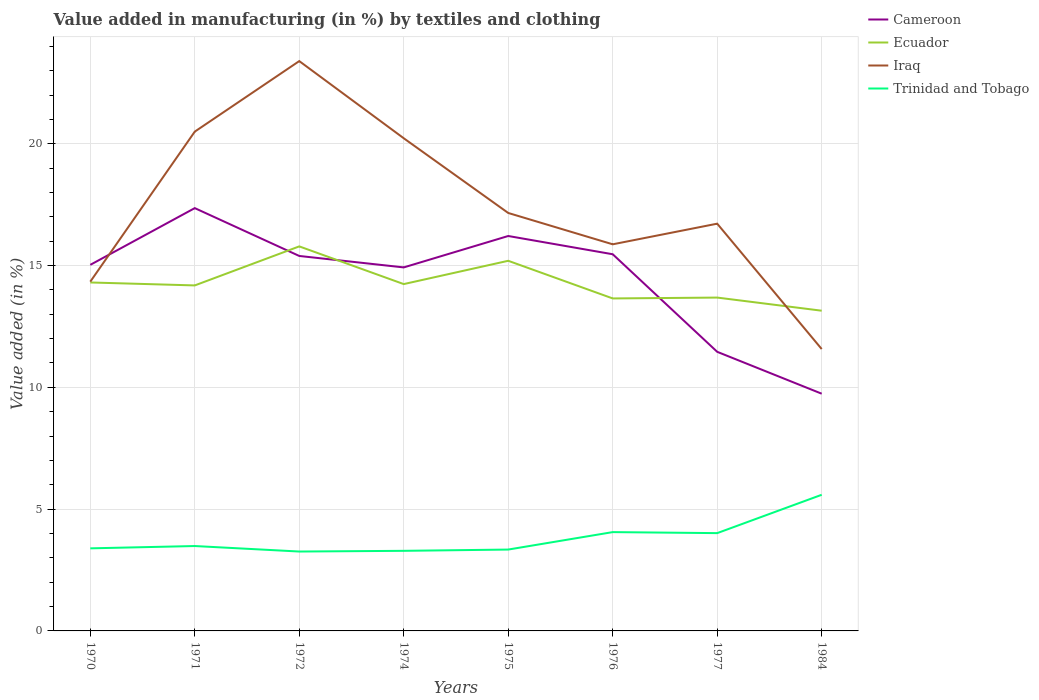Is the number of lines equal to the number of legend labels?
Your response must be concise. Yes. Across all years, what is the maximum percentage of value added in manufacturing by textiles and clothing in Trinidad and Tobago?
Keep it short and to the point. 3.26. In which year was the percentage of value added in manufacturing by textiles and clothing in Iraq maximum?
Offer a terse response. 1984. What is the total percentage of value added in manufacturing by textiles and clothing in Iraq in the graph?
Ensure brevity in your answer.  4.63. What is the difference between the highest and the second highest percentage of value added in manufacturing by textiles and clothing in Ecuador?
Ensure brevity in your answer.  2.64. What is the difference between the highest and the lowest percentage of value added in manufacturing by textiles and clothing in Cameroon?
Provide a short and direct response. 6. How many lines are there?
Make the answer very short. 4. How many years are there in the graph?
Offer a very short reply. 8. What is the difference between two consecutive major ticks on the Y-axis?
Provide a succinct answer. 5. Does the graph contain any zero values?
Offer a very short reply. No. Does the graph contain grids?
Your answer should be compact. Yes. Where does the legend appear in the graph?
Your answer should be compact. Top right. How many legend labels are there?
Provide a succinct answer. 4. How are the legend labels stacked?
Your answer should be compact. Vertical. What is the title of the graph?
Ensure brevity in your answer.  Value added in manufacturing (in %) by textiles and clothing. What is the label or title of the Y-axis?
Ensure brevity in your answer.  Value added (in %). What is the Value added (in %) in Cameroon in 1970?
Make the answer very short. 15.03. What is the Value added (in %) of Ecuador in 1970?
Make the answer very short. 14.31. What is the Value added (in %) of Iraq in 1970?
Keep it short and to the point. 14.34. What is the Value added (in %) in Trinidad and Tobago in 1970?
Offer a very short reply. 3.39. What is the Value added (in %) in Cameroon in 1971?
Provide a short and direct response. 17.36. What is the Value added (in %) of Ecuador in 1971?
Give a very brief answer. 14.18. What is the Value added (in %) of Iraq in 1971?
Keep it short and to the point. 20.5. What is the Value added (in %) in Trinidad and Tobago in 1971?
Provide a short and direct response. 3.49. What is the Value added (in %) in Cameroon in 1972?
Give a very brief answer. 15.39. What is the Value added (in %) in Ecuador in 1972?
Provide a succinct answer. 15.79. What is the Value added (in %) in Iraq in 1972?
Give a very brief answer. 23.39. What is the Value added (in %) of Trinidad and Tobago in 1972?
Keep it short and to the point. 3.26. What is the Value added (in %) of Cameroon in 1974?
Provide a short and direct response. 14.92. What is the Value added (in %) in Ecuador in 1974?
Offer a very short reply. 14.24. What is the Value added (in %) of Iraq in 1974?
Provide a succinct answer. 20.23. What is the Value added (in %) of Trinidad and Tobago in 1974?
Your answer should be compact. 3.29. What is the Value added (in %) in Cameroon in 1975?
Keep it short and to the point. 16.21. What is the Value added (in %) of Ecuador in 1975?
Offer a terse response. 15.19. What is the Value added (in %) in Iraq in 1975?
Provide a short and direct response. 17.16. What is the Value added (in %) of Trinidad and Tobago in 1975?
Ensure brevity in your answer.  3.34. What is the Value added (in %) of Cameroon in 1976?
Your answer should be very brief. 15.46. What is the Value added (in %) of Ecuador in 1976?
Ensure brevity in your answer.  13.65. What is the Value added (in %) of Iraq in 1976?
Provide a succinct answer. 15.87. What is the Value added (in %) of Trinidad and Tobago in 1976?
Provide a short and direct response. 4.06. What is the Value added (in %) in Cameroon in 1977?
Ensure brevity in your answer.  11.46. What is the Value added (in %) in Ecuador in 1977?
Give a very brief answer. 13.68. What is the Value added (in %) in Iraq in 1977?
Provide a short and direct response. 16.72. What is the Value added (in %) of Trinidad and Tobago in 1977?
Keep it short and to the point. 4.01. What is the Value added (in %) of Cameroon in 1984?
Keep it short and to the point. 9.74. What is the Value added (in %) of Ecuador in 1984?
Give a very brief answer. 13.15. What is the Value added (in %) in Iraq in 1984?
Offer a terse response. 11.57. What is the Value added (in %) of Trinidad and Tobago in 1984?
Offer a terse response. 5.59. Across all years, what is the maximum Value added (in %) in Cameroon?
Provide a short and direct response. 17.36. Across all years, what is the maximum Value added (in %) of Ecuador?
Keep it short and to the point. 15.79. Across all years, what is the maximum Value added (in %) in Iraq?
Ensure brevity in your answer.  23.39. Across all years, what is the maximum Value added (in %) in Trinidad and Tobago?
Your answer should be very brief. 5.59. Across all years, what is the minimum Value added (in %) in Cameroon?
Give a very brief answer. 9.74. Across all years, what is the minimum Value added (in %) of Ecuador?
Ensure brevity in your answer.  13.15. Across all years, what is the minimum Value added (in %) of Iraq?
Offer a terse response. 11.57. Across all years, what is the minimum Value added (in %) in Trinidad and Tobago?
Your answer should be very brief. 3.26. What is the total Value added (in %) in Cameroon in the graph?
Give a very brief answer. 115.58. What is the total Value added (in %) in Ecuador in the graph?
Offer a very short reply. 114.19. What is the total Value added (in %) of Iraq in the graph?
Offer a very short reply. 139.78. What is the total Value added (in %) of Trinidad and Tobago in the graph?
Make the answer very short. 30.42. What is the difference between the Value added (in %) of Cameroon in 1970 and that in 1971?
Make the answer very short. -2.33. What is the difference between the Value added (in %) of Ecuador in 1970 and that in 1971?
Ensure brevity in your answer.  0.12. What is the difference between the Value added (in %) in Iraq in 1970 and that in 1971?
Ensure brevity in your answer.  -6.16. What is the difference between the Value added (in %) in Trinidad and Tobago in 1970 and that in 1971?
Give a very brief answer. -0.1. What is the difference between the Value added (in %) of Cameroon in 1970 and that in 1972?
Provide a short and direct response. -0.36. What is the difference between the Value added (in %) in Ecuador in 1970 and that in 1972?
Make the answer very short. -1.48. What is the difference between the Value added (in %) of Iraq in 1970 and that in 1972?
Your response must be concise. -9.06. What is the difference between the Value added (in %) in Trinidad and Tobago in 1970 and that in 1972?
Provide a succinct answer. 0.13. What is the difference between the Value added (in %) in Cameroon in 1970 and that in 1974?
Provide a succinct answer. 0.11. What is the difference between the Value added (in %) of Ecuador in 1970 and that in 1974?
Offer a very short reply. 0.07. What is the difference between the Value added (in %) of Iraq in 1970 and that in 1974?
Offer a very short reply. -5.89. What is the difference between the Value added (in %) in Trinidad and Tobago in 1970 and that in 1974?
Offer a very short reply. 0.1. What is the difference between the Value added (in %) in Cameroon in 1970 and that in 1975?
Make the answer very short. -1.18. What is the difference between the Value added (in %) of Ecuador in 1970 and that in 1975?
Keep it short and to the point. -0.89. What is the difference between the Value added (in %) of Iraq in 1970 and that in 1975?
Keep it short and to the point. -2.82. What is the difference between the Value added (in %) of Trinidad and Tobago in 1970 and that in 1975?
Make the answer very short. 0.05. What is the difference between the Value added (in %) in Cameroon in 1970 and that in 1976?
Make the answer very short. -0.43. What is the difference between the Value added (in %) in Ecuador in 1970 and that in 1976?
Your answer should be compact. 0.66. What is the difference between the Value added (in %) of Iraq in 1970 and that in 1976?
Your answer should be compact. -1.53. What is the difference between the Value added (in %) of Trinidad and Tobago in 1970 and that in 1976?
Ensure brevity in your answer.  -0.67. What is the difference between the Value added (in %) of Cameroon in 1970 and that in 1977?
Your answer should be very brief. 3.57. What is the difference between the Value added (in %) of Ecuador in 1970 and that in 1977?
Provide a short and direct response. 0.62. What is the difference between the Value added (in %) in Iraq in 1970 and that in 1977?
Offer a terse response. -2.38. What is the difference between the Value added (in %) of Trinidad and Tobago in 1970 and that in 1977?
Offer a very short reply. -0.62. What is the difference between the Value added (in %) in Cameroon in 1970 and that in 1984?
Provide a succinct answer. 5.29. What is the difference between the Value added (in %) in Ecuador in 1970 and that in 1984?
Ensure brevity in your answer.  1.16. What is the difference between the Value added (in %) in Iraq in 1970 and that in 1984?
Your answer should be very brief. 2.77. What is the difference between the Value added (in %) in Trinidad and Tobago in 1970 and that in 1984?
Provide a succinct answer. -2.2. What is the difference between the Value added (in %) in Cameroon in 1971 and that in 1972?
Your response must be concise. 1.96. What is the difference between the Value added (in %) in Ecuador in 1971 and that in 1972?
Your response must be concise. -1.6. What is the difference between the Value added (in %) in Iraq in 1971 and that in 1972?
Provide a short and direct response. -2.9. What is the difference between the Value added (in %) in Trinidad and Tobago in 1971 and that in 1972?
Keep it short and to the point. 0.23. What is the difference between the Value added (in %) of Cameroon in 1971 and that in 1974?
Make the answer very short. 2.43. What is the difference between the Value added (in %) of Ecuador in 1971 and that in 1974?
Make the answer very short. -0.05. What is the difference between the Value added (in %) in Iraq in 1971 and that in 1974?
Provide a succinct answer. 0.27. What is the difference between the Value added (in %) in Trinidad and Tobago in 1971 and that in 1974?
Offer a very short reply. 0.2. What is the difference between the Value added (in %) in Cameroon in 1971 and that in 1975?
Your answer should be very brief. 1.14. What is the difference between the Value added (in %) in Ecuador in 1971 and that in 1975?
Ensure brevity in your answer.  -1.01. What is the difference between the Value added (in %) in Iraq in 1971 and that in 1975?
Make the answer very short. 3.34. What is the difference between the Value added (in %) of Trinidad and Tobago in 1971 and that in 1975?
Your response must be concise. 0.14. What is the difference between the Value added (in %) in Cameroon in 1971 and that in 1976?
Offer a very short reply. 1.89. What is the difference between the Value added (in %) in Ecuador in 1971 and that in 1976?
Your response must be concise. 0.53. What is the difference between the Value added (in %) of Iraq in 1971 and that in 1976?
Make the answer very short. 4.63. What is the difference between the Value added (in %) in Trinidad and Tobago in 1971 and that in 1976?
Give a very brief answer. -0.57. What is the difference between the Value added (in %) in Cameroon in 1971 and that in 1977?
Offer a very short reply. 5.9. What is the difference between the Value added (in %) in Ecuador in 1971 and that in 1977?
Provide a short and direct response. 0.5. What is the difference between the Value added (in %) of Iraq in 1971 and that in 1977?
Give a very brief answer. 3.78. What is the difference between the Value added (in %) in Trinidad and Tobago in 1971 and that in 1977?
Your answer should be very brief. -0.53. What is the difference between the Value added (in %) in Cameroon in 1971 and that in 1984?
Make the answer very short. 7.62. What is the difference between the Value added (in %) of Ecuador in 1971 and that in 1984?
Your answer should be very brief. 1.04. What is the difference between the Value added (in %) of Iraq in 1971 and that in 1984?
Your answer should be very brief. 8.93. What is the difference between the Value added (in %) of Trinidad and Tobago in 1971 and that in 1984?
Make the answer very short. -2.1. What is the difference between the Value added (in %) in Cameroon in 1972 and that in 1974?
Your answer should be very brief. 0.47. What is the difference between the Value added (in %) in Ecuador in 1972 and that in 1974?
Provide a short and direct response. 1.55. What is the difference between the Value added (in %) in Iraq in 1972 and that in 1974?
Your answer should be very brief. 3.17. What is the difference between the Value added (in %) in Trinidad and Tobago in 1972 and that in 1974?
Keep it short and to the point. -0.03. What is the difference between the Value added (in %) in Cameroon in 1972 and that in 1975?
Make the answer very short. -0.82. What is the difference between the Value added (in %) in Ecuador in 1972 and that in 1975?
Offer a terse response. 0.59. What is the difference between the Value added (in %) in Iraq in 1972 and that in 1975?
Make the answer very short. 6.24. What is the difference between the Value added (in %) in Trinidad and Tobago in 1972 and that in 1975?
Your response must be concise. -0.08. What is the difference between the Value added (in %) in Cameroon in 1972 and that in 1976?
Provide a succinct answer. -0.07. What is the difference between the Value added (in %) in Ecuador in 1972 and that in 1976?
Offer a terse response. 2.14. What is the difference between the Value added (in %) of Iraq in 1972 and that in 1976?
Provide a short and direct response. 7.52. What is the difference between the Value added (in %) in Trinidad and Tobago in 1972 and that in 1976?
Ensure brevity in your answer.  -0.8. What is the difference between the Value added (in %) of Cameroon in 1972 and that in 1977?
Offer a terse response. 3.94. What is the difference between the Value added (in %) of Ecuador in 1972 and that in 1977?
Make the answer very short. 2.1. What is the difference between the Value added (in %) in Iraq in 1972 and that in 1977?
Provide a succinct answer. 6.67. What is the difference between the Value added (in %) of Trinidad and Tobago in 1972 and that in 1977?
Offer a terse response. -0.76. What is the difference between the Value added (in %) of Cameroon in 1972 and that in 1984?
Offer a terse response. 5.65. What is the difference between the Value added (in %) of Ecuador in 1972 and that in 1984?
Ensure brevity in your answer.  2.64. What is the difference between the Value added (in %) in Iraq in 1972 and that in 1984?
Give a very brief answer. 11.82. What is the difference between the Value added (in %) in Trinidad and Tobago in 1972 and that in 1984?
Give a very brief answer. -2.33. What is the difference between the Value added (in %) of Cameroon in 1974 and that in 1975?
Give a very brief answer. -1.29. What is the difference between the Value added (in %) of Ecuador in 1974 and that in 1975?
Offer a terse response. -0.96. What is the difference between the Value added (in %) in Iraq in 1974 and that in 1975?
Make the answer very short. 3.07. What is the difference between the Value added (in %) of Trinidad and Tobago in 1974 and that in 1975?
Keep it short and to the point. -0.05. What is the difference between the Value added (in %) in Cameroon in 1974 and that in 1976?
Offer a terse response. -0.54. What is the difference between the Value added (in %) in Ecuador in 1974 and that in 1976?
Keep it short and to the point. 0.59. What is the difference between the Value added (in %) in Iraq in 1974 and that in 1976?
Your answer should be compact. 4.35. What is the difference between the Value added (in %) in Trinidad and Tobago in 1974 and that in 1976?
Keep it short and to the point. -0.77. What is the difference between the Value added (in %) in Cameroon in 1974 and that in 1977?
Offer a terse response. 3.47. What is the difference between the Value added (in %) of Ecuador in 1974 and that in 1977?
Ensure brevity in your answer.  0.55. What is the difference between the Value added (in %) in Iraq in 1974 and that in 1977?
Your answer should be compact. 3.51. What is the difference between the Value added (in %) of Trinidad and Tobago in 1974 and that in 1977?
Ensure brevity in your answer.  -0.73. What is the difference between the Value added (in %) in Cameroon in 1974 and that in 1984?
Give a very brief answer. 5.18. What is the difference between the Value added (in %) of Ecuador in 1974 and that in 1984?
Make the answer very short. 1.09. What is the difference between the Value added (in %) of Iraq in 1974 and that in 1984?
Give a very brief answer. 8.65. What is the difference between the Value added (in %) of Trinidad and Tobago in 1974 and that in 1984?
Provide a succinct answer. -2.3. What is the difference between the Value added (in %) in Cameroon in 1975 and that in 1976?
Your answer should be compact. 0.75. What is the difference between the Value added (in %) of Ecuador in 1975 and that in 1976?
Ensure brevity in your answer.  1.55. What is the difference between the Value added (in %) in Iraq in 1975 and that in 1976?
Your response must be concise. 1.29. What is the difference between the Value added (in %) of Trinidad and Tobago in 1975 and that in 1976?
Your answer should be compact. -0.72. What is the difference between the Value added (in %) of Cameroon in 1975 and that in 1977?
Give a very brief answer. 4.75. What is the difference between the Value added (in %) in Ecuador in 1975 and that in 1977?
Provide a short and direct response. 1.51. What is the difference between the Value added (in %) of Iraq in 1975 and that in 1977?
Ensure brevity in your answer.  0.44. What is the difference between the Value added (in %) of Trinidad and Tobago in 1975 and that in 1977?
Your answer should be very brief. -0.67. What is the difference between the Value added (in %) in Cameroon in 1975 and that in 1984?
Ensure brevity in your answer.  6.47. What is the difference between the Value added (in %) of Ecuador in 1975 and that in 1984?
Your answer should be very brief. 2.05. What is the difference between the Value added (in %) of Iraq in 1975 and that in 1984?
Offer a very short reply. 5.59. What is the difference between the Value added (in %) of Trinidad and Tobago in 1975 and that in 1984?
Your answer should be compact. -2.25. What is the difference between the Value added (in %) of Cameroon in 1976 and that in 1977?
Your response must be concise. 4.01. What is the difference between the Value added (in %) of Ecuador in 1976 and that in 1977?
Make the answer very short. -0.04. What is the difference between the Value added (in %) of Iraq in 1976 and that in 1977?
Provide a short and direct response. -0.85. What is the difference between the Value added (in %) of Trinidad and Tobago in 1976 and that in 1977?
Provide a succinct answer. 0.04. What is the difference between the Value added (in %) in Cameroon in 1976 and that in 1984?
Keep it short and to the point. 5.72. What is the difference between the Value added (in %) in Ecuador in 1976 and that in 1984?
Provide a succinct answer. 0.5. What is the difference between the Value added (in %) in Iraq in 1976 and that in 1984?
Provide a short and direct response. 4.3. What is the difference between the Value added (in %) in Trinidad and Tobago in 1976 and that in 1984?
Ensure brevity in your answer.  -1.53. What is the difference between the Value added (in %) in Cameroon in 1977 and that in 1984?
Ensure brevity in your answer.  1.72. What is the difference between the Value added (in %) in Ecuador in 1977 and that in 1984?
Offer a terse response. 0.54. What is the difference between the Value added (in %) in Iraq in 1977 and that in 1984?
Give a very brief answer. 5.15. What is the difference between the Value added (in %) of Trinidad and Tobago in 1977 and that in 1984?
Offer a terse response. -1.57. What is the difference between the Value added (in %) of Cameroon in 1970 and the Value added (in %) of Ecuador in 1971?
Your answer should be very brief. 0.84. What is the difference between the Value added (in %) in Cameroon in 1970 and the Value added (in %) in Iraq in 1971?
Keep it short and to the point. -5.47. What is the difference between the Value added (in %) of Cameroon in 1970 and the Value added (in %) of Trinidad and Tobago in 1971?
Your response must be concise. 11.54. What is the difference between the Value added (in %) in Ecuador in 1970 and the Value added (in %) in Iraq in 1971?
Give a very brief answer. -6.19. What is the difference between the Value added (in %) in Ecuador in 1970 and the Value added (in %) in Trinidad and Tobago in 1971?
Your answer should be compact. 10.82. What is the difference between the Value added (in %) of Iraq in 1970 and the Value added (in %) of Trinidad and Tobago in 1971?
Make the answer very short. 10.85. What is the difference between the Value added (in %) in Cameroon in 1970 and the Value added (in %) in Ecuador in 1972?
Make the answer very short. -0.76. What is the difference between the Value added (in %) of Cameroon in 1970 and the Value added (in %) of Iraq in 1972?
Give a very brief answer. -8.36. What is the difference between the Value added (in %) of Cameroon in 1970 and the Value added (in %) of Trinidad and Tobago in 1972?
Provide a succinct answer. 11.77. What is the difference between the Value added (in %) in Ecuador in 1970 and the Value added (in %) in Iraq in 1972?
Your answer should be very brief. -9.09. What is the difference between the Value added (in %) in Ecuador in 1970 and the Value added (in %) in Trinidad and Tobago in 1972?
Provide a short and direct response. 11.05. What is the difference between the Value added (in %) of Iraq in 1970 and the Value added (in %) of Trinidad and Tobago in 1972?
Offer a very short reply. 11.08. What is the difference between the Value added (in %) of Cameroon in 1970 and the Value added (in %) of Ecuador in 1974?
Your response must be concise. 0.79. What is the difference between the Value added (in %) of Cameroon in 1970 and the Value added (in %) of Iraq in 1974?
Provide a short and direct response. -5.2. What is the difference between the Value added (in %) of Cameroon in 1970 and the Value added (in %) of Trinidad and Tobago in 1974?
Give a very brief answer. 11.74. What is the difference between the Value added (in %) of Ecuador in 1970 and the Value added (in %) of Iraq in 1974?
Keep it short and to the point. -5.92. What is the difference between the Value added (in %) in Ecuador in 1970 and the Value added (in %) in Trinidad and Tobago in 1974?
Your response must be concise. 11.02. What is the difference between the Value added (in %) of Iraq in 1970 and the Value added (in %) of Trinidad and Tobago in 1974?
Ensure brevity in your answer.  11.05. What is the difference between the Value added (in %) of Cameroon in 1970 and the Value added (in %) of Ecuador in 1975?
Your response must be concise. -0.17. What is the difference between the Value added (in %) of Cameroon in 1970 and the Value added (in %) of Iraq in 1975?
Make the answer very short. -2.13. What is the difference between the Value added (in %) in Cameroon in 1970 and the Value added (in %) in Trinidad and Tobago in 1975?
Ensure brevity in your answer.  11.69. What is the difference between the Value added (in %) in Ecuador in 1970 and the Value added (in %) in Iraq in 1975?
Provide a succinct answer. -2.85. What is the difference between the Value added (in %) of Ecuador in 1970 and the Value added (in %) of Trinidad and Tobago in 1975?
Offer a very short reply. 10.96. What is the difference between the Value added (in %) of Iraq in 1970 and the Value added (in %) of Trinidad and Tobago in 1975?
Offer a terse response. 11. What is the difference between the Value added (in %) of Cameroon in 1970 and the Value added (in %) of Ecuador in 1976?
Ensure brevity in your answer.  1.38. What is the difference between the Value added (in %) in Cameroon in 1970 and the Value added (in %) in Iraq in 1976?
Offer a terse response. -0.84. What is the difference between the Value added (in %) in Cameroon in 1970 and the Value added (in %) in Trinidad and Tobago in 1976?
Offer a terse response. 10.97. What is the difference between the Value added (in %) of Ecuador in 1970 and the Value added (in %) of Iraq in 1976?
Your answer should be compact. -1.57. What is the difference between the Value added (in %) of Ecuador in 1970 and the Value added (in %) of Trinidad and Tobago in 1976?
Provide a short and direct response. 10.25. What is the difference between the Value added (in %) of Iraq in 1970 and the Value added (in %) of Trinidad and Tobago in 1976?
Keep it short and to the point. 10.28. What is the difference between the Value added (in %) in Cameroon in 1970 and the Value added (in %) in Ecuador in 1977?
Your answer should be compact. 1.34. What is the difference between the Value added (in %) of Cameroon in 1970 and the Value added (in %) of Iraq in 1977?
Offer a terse response. -1.69. What is the difference between the Value added (in %) of Cameroon in 1970 and the Value added (in %) of Trinidad and Tobago in 1977?
Make the answer very short. 11.01. What is the difference between the Value added (in %) in Ecuador in 1970 and the Value added (in %) in Iraq in 1977?
Keep it short and to the point. -2.41. What is the difference between the Value added (in %) in Ecuador in 1970 and the Value added (in %) in Trinidad and Tobago in 1977?
Offer a very short reply. 10.29. What is the difference between the Value added (in %) of Iraq in 1970 and the Value added (in %) of Trinidad and Tobago in 1977?
Your answer should be very brief. 10.32. What is the difference between the Value added (in %) of Cameroon in 1970 and the Value added (in %) of Ecuador in 1984?
Provide a succinct answer. 1.88. What is the difference between the Value added (in %) in Cameroon in 1970 and the Value added (in %) in Iraq in 1984?
Your response must be concise. 3.46. What is the difference between the Value added (in %) of Cameroon in 1970 and the Value added (in %) of Trinidad and Tobago in 1984?
Offer a very short reply. 9.44. What is the difference between the Value added (in %) of Ecuador in 1970 and the Value added (in %) of Iraq in 1984?
Give a very brief answer. 2.73. What is the difference between the Value added (in %) of Ecuador in 1970 and the Value added (in %) of Trinidad and Tobago in 1984?
Your answer should be compact. 8.72. What is the difference between the Value added (in %) in Iraq in 1970 and the Value added (in %) in Trinidad and Tobago in 1984?
Ensure brevity in your answer.  8.75. What is the difference between the Value added (in %) in Cameroon in 1971 and the Value added (in %) in Ecuador in 1972?
Provide a short and direct response. 1.57. What is the difference between the Value added (in %) in Cameroon in 1971 and the Value added (in %) in Iraq in 1972?
Your response must be concise. -6.04. What is the difference between the Value added (in %) in Cameroon in 1971 and the Value added (in %) in Trinidad and Tobago in 1972?
Offer a very short reply. 14.1. What is the difference between the Value added (in %) in Ecuador in 1971 and the Value added (in %) in Iraq in 1972?
Your answer should be compact. -9.21. What is the difference between the Value added (in %) in Ecuador in 1971 and the Value added (in %) in Trinidad and Tobago in 1972?
Provide a short and direct response. 10.92. What is the difference between the Value added (in %) of Iraq in 1971 and the Value added (in %) of Trinidad and Tobago in 1972?
Offer a very short reply. 17.24. What is the difference between the Value added (in %) in Cameroon in 1971 and the Value added (in %) in Ecuador in 1974?
Provide a short and direct response. 3.12. What is the difference between the Value added (in %) of Cameroon in 1971 and the Value added (in %) of Iraq in 1974?
Your answer should be compact. -2.87. What is the difference between the Value added (in %) of Cameroon in 1971 and the Value added (in %) of Trinidad and Tobago in 1974?
Provide a succinct answer. 14.07. What is the difference between the Value added (in %) in Ecuador in 1971 and the Value added (in %) in Iraq in 1974?
Your answer should be very brief. -6.04. What is the difference between the Value added (in %) in Ecuador in 1971 and the Value added (in %) in Trinidad and Tobago in 1974?
Your response must be concise. 10.9. What is the difference between the Value added (in %) of Iraq in 1971 and the Value added (in %) of Trinidad and Tobago in 1974?
Provide a succinct answer. 17.21. What is the difference between the Value added (in %) of Cameroon in 1971 and the Value added (in %) of Ecuador in 1975?
Your answer should be compact. 2.16. What is the difference between the Value added (in %) of Cameroon in 1971 and the Value added (in %) of Iraq in 1975?
Your answer should be compact. 0.2. What is the difference between the Value added (in %) in Cameroon in 1971 and the Value added (in %) in Trinidad and Tobago in 1975?
Make the answer very short. 14.02. What is the difference between the Value added (in %) in Ecuador in 1971 and the Value added (in %) in Iraq in 1975?
Make the answer very short. -2.97. What is the difference between the Value added (in %) of Ecuador in 1971 and the Value added (in %) of Trinidad and Tobago in 1975?
Offer a very short reply. 10.84. What is the difference between the Value added (in %) in Iraq in 1971 and the Value added (in %) in Trinidad and Tobago in 1975?
Make the answer very short. 17.16. What is the difference between the Value added (in %) in Cameroon in 1971 and the Value added (in %) in Ecuador in 1976?
Make the answer very short. 3.71. What is the difference between the Value added (in %) of Cameroon in 1971 and the Value added (in %) of Iraq in 1976?
Your answer should be very brief. 1.49. What is the difference between the Value added (in %) in Cameroon in 1971 and the Value added (in %) in Trinidad and Tobago in 1976?
Your response must be concise. 13.3. What is the difference between the Value added (in %) in Ecuador in 1971 and the Value added (in %) in Iraq in 1976?
Your answer should be very brief. -1.69. What is the difference between the Value added (in %) of Ecuador in 1971 and the Value added (in %) of Trinidad and Tobago in 1976?
Offer a terse response. 10.13. What is the difference between the Value added (in %) of Iraq in 1971 and the Value added (in %) of Trinidad and Tobago in 1976?
Give a very brief answer. 16.44. What is the difference between the Value added (in %) of Cameroon in 1971 and the Value added (in %) of Ecuador in 1977?
Make the answer very short. 3.67. What is the difference between the Value added (in %) in Cameroon in 1971 and the Value added (in %) in Iraq in 1977?
Your response must be concise. 0.64. What is the difference between the Value added (in %) in Cameroon in 1971 and the Value added (in %) in Trinidad and Tobago in 1977?
Offer a very short reply. 13.34. What is the difference between the Value added (in %) in Ecuador in 1971 and the Value added (in %) in Iraq in 1977?
Give a very brief answer. -2.53. What is the difference between the Value added (in %) in Ecuador in 1971 and the Value added (in %) in Trinidad and Tobago in 1977?
Provide a short and direct response. 10.17. What is the difference between the Value added (in %) of Iraq in 1971 and the Value added (in %) of Trinidad and Tobago in 1977?
Ensure brevity in your answer.  16.48. What is the difference between the Value added (in %) of Cameroon in 1971 and the Value added (in %) of Ecuador in 1984?
Your response must be concise. 4.21. What is the difference between the Value added (in %) of Cameroon in 1971 and the Value added (in %) of Iraq in 1984?
Keep it short and to the point. 5.79. What is the difference between the Value added (in %) in Cameroon in 1971 and the Value added (in %) in Trinidad and Tobago in 1984?
Ensure brevity in your answer.  11.77. What is the difference between the Value added (in %) in Ecuador in 1971 and the Value added (in %) in Iraq in 1984?
Your answer should be very brief. 2.61. What is the difference between the Value added (in %) of Ecuador in 1971 and the Value added (in %) of Trinidad and Tobago in 1984?
Your answer should be compact. 8.6. What is the difference between the Value added (in %) of Iraq in 1971 and the Value added (in %) of Trinidad and Tobago in 1984?
Keep it short and to the point. 14.91. What is the difference between the Value added (in %) of Cameroon in 1972 and the Value added (in %) of Ecuador in 1974?
Provide a succinct answer. 1.16. What is the difference between the Value added (in %) in Cameroon in 1972 and the Value added (in %) in Iraq in 1974?
Ensure brevity in your answer.  -4.83. What is the difference between the Value added (in %) of Cameroon in 1972 and the Value added (in %) of Trinidad and Tobago in 1974?
Give a very brief answer. 12.11. What is the difference between the Value added (in %) in Ecuador in 1972 and the Value added (in %) in Iraq in 1974?
Give a very brief answer. -4.44. What is the difference between the Value added (in %) in Ecuador in 1972 and the Value added (in %) in Trinidad and Tobago in 1974?
Give a very brief answer. 12.5. What is the difference between the Value added (in %) of Iraq in 1972 and the Value added (in %) of Trinidad and Tobago in 1974?
Offer a terse response. 20.11. What is the difference between the Value added (in %) in Cameroon in 1972 and the Value added (in %) in Ecuador in 1975?
Offer a terse response. 0.2. What is the difference between the Value added (in %) of Cameroon in 1972 and the Value added (in %) of Iraq in 1975?
Provide a short and direct response. -1.76. What is the difference between the Value added (in %) of Cameroon in 1972 and the Value added (in %) of Trinidad and Tobago in 1975?
Your response must be concise. 12.05. What is the difference between the Value added (in %) in Ecuador in 1972 and the Value added (in %) in Iraq in 1975?
Your response must be concise. -1.37. What is the difference between the Value added (in %) in Ecuador in 1972 and the Value added (in %) in Trinidad and Tobago in 1975?
Give a very brief answer. 12.45. What is the difference between the Value added (in %) of Iraq in 1972 and the Value added (in %) of Trinidad and Tobago in 1975?
Give a very brief answer. 20.05. What is the difference between the Value added (in %) in Cameroon in 1972 and the Value added (in %) in Ecuador in 1976?
Provide a short and direct response. 1.74. What is the difference between the Value added (in %) of Cameroon in 1972 and the Value added (in %) of Iraq in 1976?
Your answer should be compact. -0.48. What is the difference between the Value added (in %) of Cameroon in 1972 and the Value added (in %) of Trinidad and Tobago in 1976?
Ensure brevity in your answer.  11.34. What is the difference between the Value added (in %) of Ecuador in 1972 and the Value added (in %) of Iraq in 1976?
Make the answer very short. -0.09. What is the difference between the Value added (in %) of Ecuador in 1972 and the Value added (in %) of Trinidad and Tobago in 1976?
Keep it short and to the point. 11.73. What is the difference between the Value added (in %) in Iraq in 1972 and the Value added (in %) in Trinidad and Tobago in 1976?
Your answer should be compact. 19.34. What is the difference between the Value added (in %) of Cameroon in 1972 and the Value added (in %) of Ecuador in 1977?
Offer a terse response. 1.71. What is the difference between the Value added (in %) of Cameroon in 1972 and the Value added (in %) of Iraq in 1977?
Offer a very short reply. -1.33. What is the difference between the Value added (in %) in Cameroon in 1972 and the Value added (in %) in Trinidad and Tobago in 1977?
Your answer should be very brief. 11.38. What is the difference between the Value added (in %) of Ecuador in 1972 and the Value added (in %) of Iraq in 1977?
Your response must be concise. -0.93. What is the difference between the Value added (in %) of Ecuador in 1972 and the Value added (in %) of Trinidad and Tobago in 1977?
Ensure brevity in your answer.  11.77. What is the difference between the Value added (in %) of Iraq in 1972 and the Value added (in %) of Trinidad and Tobago in 1977?
Your answer should be compact. 19.38. What is the difference between the Value added (in %) in Cameroon in 1972 and the Value added (in %) in Ecuador in 1984?
Offer a terse response. 2.25. What is the difference between the Value added (in %) of Cameroon in 1972 and the Value added (in %) of Iraq in 1984?
Your answer should be compact. 3.82. What is the difference between the Value added (in %) in Cameroon in 1972 and the Value added (in %) in Trinidad and Tobago in 1984?
Ensure brevity in your answer.  9.8. What is the difference between the Value added (in %) of Ecuador in 1972 and the Value added (in %) of Iraq in 1984?
Give a very brief answer. 4.21. What is the difference between the Value added (in %) in Ecuador in 1972 and the Value added (in %) in Trinidad and Tobago in 1984?
Give a very brief answer. 10.2. What is the difference between the Value added (in %) in Iraq in 1972 and the Value added (in %) in Trinidad and Tobago in 1984?
Your response must be concise. 17.8. What is the difference between the Value added (in %) in Cameroon in 1974 and the Value added (in %) in Ecuador in 1975?
Keep it short and to the point. -0.27. What is the difference between the Value added (in %) in Cameroon in 1974 and the Value added (in %) in Iraq in 1975?
Your answer should be compact. -2.23. What is the difference between the Value added (in %) in Cameroon in 1974 and the Value added (in %) in Trinidad and Tobago in 1975?
Provide a short and direct response. 11.58. What is the difference between the Value added (in %) in Ecuador in 1974 and the Value added (in %) in Iraq in 1975?
Keep it short and to the point. -2.92. What is the difference between the Value added (in %) of Ecuador in 1974 and the Value added (in %) of Trinidad and Tobago in 1975?
Make the answer very short. 10.9. What is the difference between the Value added (in %) in Iraq in 1974 and the Value added (in %) in Trinidad and Tobago in 1975?
Offer a terse response. 16.89. What is the difference between the Value added (in %) in Cameroon in 1974 and the Value added (in %) in Ecuador in 1976?
Your answer should be very brief. 1.27. What is the difference between the Value added (in %) of Cameroon in 1974 and the Value added (in %) of Iraq in 1976?
Give a very brief answer. -0.95. What is the difference between the Value added (in %) of Cameroon in 1974 and the Value added (in %) of Trinidad and Tobago in 1976?
Give a very brief answer. 10.87. What is the difference between the Value added (in %) in Ecuador in 1974 and the Value added (in %) in Iraq in 1976?
Provide a succinct answer. -1.63. What is the difference between the Value added (in %) of Ecuador in 1974 and the Value added (in %) of Trinidad and Tobago in 1976?
Your answer should be very brief. 10.18. What is the difference between the Value added (in %) in Iraq in 1974 and the Value added (in %) in Trinidad and Tobago in 1976?
Make the answer very short. 16.17. What is the difference between the Value added (in %) of Cameroon in 1974 and the Value added (in %) of Ecuador in 1977?
Provide a succinct answer. 1.24. What is the difference between the Value added (in %) in Cameroon in 1974 and the Value added (in %) in Iraq in 1977?
Provide a short and direct response. -1.8. What is the difference between the Value added (in %) in Cameroon in 1974 and the Value added (in %) in Trinidad and Tobago in 1977?
Provide a succinct answer. 10.91. What is the difference between the Value added (in %) in Ecuador in 1974 and the Value added (in %) in Iraq in 1977?
Your response must be concise. -2.48. What is the difference between the Value added (in %) in Ecuador in 1974 and the Value added (in %) in Trinidad and Tobago in 1977?
Ensure brevity in your answer.  10.22. What is the difference between the Value added (in %) of Iraq in 1974 and the Value added (in %) of Trinidad and Tobago in 1977?
Give a very brief answer. 16.21. What is the difference between the Value added (in %) in Cameroon in 1974 and the Value added (in %) in Ecuador in 1984?
Offer a very short reply. 1.78. What is the difference between the Value added (in %) of Cameroon in 1974 and the Value added (in %) of Iraq in 1984?
Ensure brevity in your answer.  3.35. What is the difference between the Value added (in %) of Cameroon in 1974 and the Value added (in %) of Trinidad and Tobago in 1984?
Provide a succinct answer. 9.33. What is the difference between the Value added (in %) of Ecuador in 1974 and the Value added (in %) of Iraq in 1984?
Your response must be concise. 2.67. What is the difference between the Value added (in %) of Ecuador in 1974 and the Value added (in %) of Trinidad and Tobago in 1984?
Your answer should be compact. 8.65. What is the difference between the Value added (in %) in Iraq in 1974 and the Value added (in %) in Trinidad and Tobago in 1984?
Make the answer very short. 14.64. What is the difference between the Value added (in %) in Cameroon in 1975 and the Value added (in %) in Ecuador in 1976?
Provide a short and direct response. 2.56. What is the difference between the Value added (in %) in Cameroon in 1975 and the Value added (in %) in Iraq in 1976?
Offer a terse response. 0.34. What is the difference between the Value added (in %) of Cameroon in 1975 and the Value added (in %) of Trinidad and Tobago in 1976?
Your answer should be very brief. 12.16. What is the difference between the Value added (in %) in Ecuador in 1975 and the Value added (in %) in Iraq in 1976?
Provide a succinct answer. -0.68. What is the difference between the Value added (in %) of Ecuador in 1975 and the Value added (in %) of Trinidad and Tobago in 1976?
Ensure brevity in your answer.  11.14. What is the difference between the Value added (in %) of Iraq in 1975 and the Value added (in %) of Trinidad and Tobago in 1976?
Give a very brief answer. 13.1. What is the difference between the Value added (in %) in Cameroon in 1975 and the Value added (in %) in Ecuador in 1977?
Your response must be concise. 2.53. What is the difference between the Value added (in %) of Cameroon in 1975 and the Value added (in %) of Iraq in 1977?
Your answer should be very brief. -0.51. What is the difference between the Value added (in %) in Cameroon in 1975 and the Value added (in %) in Trinidad and Tobago in 1977?
Offer a very short reply. 12.2. What is the difference between the Value added (in %) of Ecuador in 1975 and the Value added (in %) of Iraq in 1977?
Your answer should be compact. -1.52. What is the difference between the Value added (in %) in Ecuador in 1975 and the Value added (in %) in Trinidad and Tobago in 1977?
Give a very brief answer. 11.18. What is the difference between the Value added (in %) in Iraq in 1975 and the Value added (in %) in Trinidad and Tobago in 1977?
Your response must be concise. 13.14. What is the difference between the Value added (in %) in Cameroon in 1975 and the Value added (in %) in Ecuador in 1984?
Offer a very short reply. 3.07. What is the difference between the Value added (in %) in Cameroon in 1975 and the Value added (in %) in Iraq in 1984?
Offer a terse response. 4.64. What is the difference between the Value added (in %) of Cameroon in 1975 and the Value added (in %) of Trinidad and Tobago in 1984?
Provide a succinct answer. 10.62. What is the difference between the Value added (in %) in Ecuador in 1975 and the Value added (in %) in Iraq in 1984?
Offer a very short reply. 3.62. What is the difference between the Value added (in %) in Ecuador in 1975 and the Value added (in %) in Trinidad and Tobago in 1984?
Provide a short and direct response. 9.61. What is the difference between the Value added (in %) of Iraq in 1975 and the Value added (in %) of Trinidad and Tobago in 1984?
Ensure brevity in your answer.  11.57. What is the difference between the Value added (in %) in Cameroon in 1976 and the Value added (in %) in Ecuador in 1977?
Keep it short and to the point. 1.78. What is the difference between the Value added (in %) of Cameroon in 1976 and the Value added (in %) of Iraq in 1977?
Provide a short and direct response. -1.26. What is the difference between the Value added (in %) of Cameroon in 1976 and the Value added (in %) of Trinidad and Tobago in 1977?
Your answer should be very brief. 11.45. What is the difference between the Value added (in %) in Ecuador in 1976 and the Value added (in %) in Iraq in 1977?
Your response must be concise. -3.07. What is the difference between the Value added (in %) in Ecuador in 1976 and the Value added (in %) in Trinidad and Tobago in 1977?
Make the answer very short. 9.63. What is the difference between the Value added (in %) in Iraq in 1976 and the Value added (in %) in Trinidad and Tobago in 1977?
Make the answer very short. 11.86. What is the difference between the Value added (in %) in Cameroon in 1976 and the Value added (in %) in Ecuador in 1984?
Ensure brevity in your answer.  2.32. What is the difference between the Value added (in %) in Cameroon in 1976 and the Value added (in %) in Iraq in 1984?
Offer a terse response. 3.89. What is the difference between the Value added (in %) in Cameroon in 1976 and the Value added (in %) in Trinidad and Tobago in 1984?
Provide a succinct answer. 9.88. What is the difference between the Value added (in %) in Ecuador in 1976 and the Value added (in %) in Iraq in 1984?
Give a very brief answer. 2.08. What is the difference between the Value added (in %) in Ecuador in 1976 and the Value added (in %) in Trinidad and Tobago in 1984?
Ensure brevity in your answer.  8.06. What is the difference between the Value added (in %) of Iraq in 1976 and the Value added (in %) of Trinidad and Tobago in 1984?
Your answer should be very brief. 10.28. What is the difference between the Value added (in %) of Cameroon in 1977 and the Value added (in %) of Ecuador in 1984?
Make the answer very short. -1.69. What is the difference between the Value added (in %) of Cameroon in 1977 and the Value added (in %) of Iraq in 1984?
Ensure brevity in your answer.  -0.11. What is the difference between the Value added (in %) in Cameroon in 1977 and the Value added (in %) in Trinidad and Tobago in 1984?
Keep it short and to the point. 5.87. What is the difference between the Value added (in %) of Ecuador in 1977 and the Value added (in %) of Iraq in 1984?
Provide a short and direct response. 2.11. What is the difference between the Value added (in %) in Ecuador in 1977 and the Value added (in %) in Trinidad and Tobago in 1984?
Your answer should be compact. 8.1. What is the difference between the Value added (in %) of Iraq in 1977 and the Value added (in %) of Trinidad and Tobago in 1984?
Keep it short and to the point. 11.13. What is the average Value added (in %) in Cameroon per year?
Provide a succinct answer. 14.45. What is the average Value added (in %) in Ecuador per year?
Offer a terse response. 14.27. What is the average Value added (in %) of Iraq per year?
Provide a succinct answer. 17.47. What is the average Value added (in %) of Trinidad and Tobago per year?
Your answer should be compact. 3.8. In the year 1970, what is the difference between the Value added (in %) of Cameroon and Value added (in %) of Ecuador?
Offer a terse response. 0.72. In the year 1970, what is the difference between the Value added (in %) in Cameroon and Value added (in %) in Iraq?
Offer a terse response. 0.69. In the year 1970, what is the difference between the Value added (in %) of Cameroon and Value added (in %) of Trinidad and Tobago?
Your answer should be compact. 11.64. In the year 1970, what is the difference between the Value added (in %) in Ecuador and Value added (in %) in Iraq?
Keep it short and to the point. -0.03. In the year 1970, what is the difference between the Value added (in %) in Ecuador and Value added (in %) in Trinidad and Tobago?
Offer a very short reply. 10.92. In the year 1970, what is the difference between the Value added (in %) in Iraq and Value added (in %) in Trinidad and Tobago?
Your response must be concise. 10.95. In the year 1971, what is the difference between the Value added (in %) in Cameroon and Value added (in %) in Ecuador?
Provide a succinct answer. 3.17. In the year 1971, what is the difference between the Value added (in %) of Cameroon and Value added (in %) of Iraq?
Keep it short and to the point. -3.14. In the year 1971, what is the difference between the Value added (in %) in Cameroon and Value added (in %) in Trinidad and Tobago?
Give a very brief answer. 13.87. In the year 1971, what is the difference between the Value added (in %) of Ecuador and Value added (in %) of Iraq?
Your answer should be very brief. -6.31. In the year 1971, what is the difference between the Value added (in %) in Ecuador and Value added (in %) in Trinidad and Tobago?
Make the answer very short. 10.7. In the year 1971, what is the difference between the Value added (in %) of Iraq and Value added (in %) of Trinidad and Tobago?
Offer a very short reply. 17.01. In the year 1972, what is the difference between the Value added (in %) of Cameroon and Value added (in %) of Ecuador?
Your answer should be very brief. -0.39. In the year 1972, what is the difference between the Value added (in %) in Cameroon and Value added (in %) in Iraq?
Your response must be concise. -8. In the year 1972, what is the difference between the Value added (in %) of Cameroon and Value added (in %) of Trinidad and Tobago?
Offer a very short reply. 12.13. In the year 1972, what is the difference between the Value added (in %) of Ecuador and Value added (in %) of Iraq?
Make the answer very short. -7.61. In the year 1972, what is the difference between the Value added (in %) of Ecuador and Value added (in %) of Trinidad and Tobago?
Your answer should be very brief. 12.53. In the year 1972, what is the difference between the Value added (in %) of Iraq and Value added (in %) of Trinidad and Tobago?
Provide a short and direct response. 20.13. In the year 1974, what is the difference between the Value added (in %) of Cameroon and Value added (in %) of Ecuador?
Offer a very short reply. 0.69. In the year 1974, what is the difference between the Value added (in %) in Cameroon and Value added (in %) in Iraq?
Ensure brevity in your answer.  -5.3. In the year 1974, what is the difference between the Value added (in %) in Cameroon and Value added (in %) in Trinidad and Tobago?
Offer a terse response. 11.64. In the year 1974, what is the difference between the Value added (in %) of Ecuador and Value added (in %) of Iraq?
Your answer should be compact. -5.99. In the year 1974, what is the difference between the Value added (in %) in Ecuador and Value added (in %) in Trinidad and Tobago?
Offer a very short reply. 10.95. In the year 1974, what is the difference between the Value added (in %) of Iraq and Value added (in %) of Trinidad and Tobago?
Make the answer very short. 16.94. In the year 1975, what is the difference between the Value added (in %) of Cameroon and Value added (in %) of Ecuador?
Your answer should be compact. 1.02. In the year 1975, what is the difference between the Value added (in %) of Cameroon and Value added (in %) of Iraq?
Offer a terse response. -0.94. In the year 1975, what is the difference between the Value added (in %) in Cameroon and Value added (in %) in Trinidad and Tobago?
Keep it short and to the point. 12.87. In the year 1975, what is the difference between the Value added (in %) in Ecuador and Value added (in %) in Iraq?
Provide a succinct answer. -1.96. In the year 1975, what is the difference between the Value added (in %) of Ecuador and Value added (in %) of Trinidad and Tobago?
Ensure brevity in your answer.  11.85. In the year 1975, what is the difference between the Value added (in %) in Iraq and Value added (in %) in Trinidad and Tobago?
Your response must be concise. 13.82. In the year 1976, what is the difference between the Value added (in %) in Cameroon and Value added (in %) in Ecuador?
Provide a short and direct response. 1.81. In the year 1976, what is the difference between the Value added (in %) of Cameroon and Value added (in %) of Iraq?
Offer a very short reply. -0.41. In the year 1976, what is the difference between the Value added (in %) in Cameroon and Value added (in %) in Trinidad and Tobago?
Give a very brief answer. 11.41. In the year 1976, what is the difference between the Value added (in %) in Ecuador and Value added (in %) in Iraq?
Your answer should be compact. -2.22. In the year 1976, what is the difference between the Value added (in %) in Ecuador and Value added (in %) in Trinidad and Tobago?
Offer a very short reply. 9.59. In the year 1976, what is the difference between the Value added (in %) of Iraq and Value added (in %) of Trinidad and Tobago?
Give a very brief answer. 11.82. In the year 1977, what is the difference between the Value added (in %) of Cameroon and Value added (in %) of Ecuador?
Make the answer very short. -2.23. In the year 1977, what is the difference between the Value added (in %) of Cameroon and Value added (in %) of Iraq?
Give a very brief answer. -5.26. In the year 1977, what is the difference between the Value added (in %) of Cameroon and Value added (in %) of Trinidad and Tobago?
Your answer should be compact. 7.44. In the year 1977, what is the difference between the Value added (in %) of Ecuador and Value added (in %) of Iraq?
Keep it short and to the point. -3.03. In the year 1977, what is the difference between the Value added (in %) of Ecuador and Value added (in %) of Trinidad and Tobago?
Your response must be concise. 9.67. In the year 1977, what is the difference between the Value added (in %) in Iraq and Value added (in %) in Trinidad and Tobago?
Give a very brief answer. 12.7. In the year 1984, what is the difference between the Value added (in %) of Cameroon and Value added (in %) of Ecuador?
Give a very brief answer. -3.41. In the year 1984, what is the difference between the Value added (in %) in Cameroon and Value added (in %) in Iraq?
Offer a terse response. -1.83. In the year 1984, what is the difference between the Value added (in %) in Cameroon and Value added (in %) in Trinidad and Tobago?
Provide a succinct answer. 4.15. In the year 1984, what is the difference between the Value added (in %) of Ecuador and Value added (in %) of Iraq?
Offer a very short reply. 1.57. In the year 1984, what is the difference between the Value added (in %) of Ecuador and Value added (in %) of Trinidad and Tobago?
Give a very brief answer. 7.56. In the year 1984, what is the difference between the Value added (in %) of Iraq and Value added (in %) of Trinidad and Tobago?
Give a very brief answer. 5.98. What is the ratio of the Value added (in %) of Cameroon in 1970 to that in 1971?
Your answer should be very brief. 0.87. What is the ratio of the Value added (in %) of Ecuador in 1970 to that in 1971?
Offer a very short reply. 1.01. What is the ratio of the Value added (in %) of Iraq in 1970 to that in 1971?
Give a very brief answer. 0.7. What is the ratio of the Value added (in %) in Trinidad and Tobago in 1970 to that in 1971?
Offer a terse response. 0.97. What is the ratio of the Value added (in %) in Cameroon in 1970 to that in 1972?
Make the answer very short. 0.98. What is the ratio of the Value added (in %) of Ecuador in 1970 to that in 1972?
Provide a succinct answer. 0.91. What is the ratio of the Value added (in %) in Iraq in 1970 to that in 1972?
Offer a very short reply. 0.61. What is the ratio of the Value added (in %) of Trinidad and Tobago in 1970 to that in 1972?
Make the answer very short. 1.04. What is the ratio of the Value added (in %) of Cameroon in 1970 to that in 1974?
Give a very brief answer. 1.01. What is the ratio of the Value added (in %) of Iraq in 1970 to that in 1974?
Provide a short and direct response. 0.71. What is the ratio of the Value added (in %) in Trinidad and Tobago in 1970 to that in 1974?
Ensure brevity in your answer.  1.03. What is the ratio of the Value added (in %) of Cameroon in 1970 to that in 1975?
Offer a terse response. 0.93. What is the ratio of the Value added (in %) in Ecuador in 1970 to that in 1975?
Offer a terse response. 0.94. What is the ratio of the Value added (in %) in Iraq in 1970 to that in 1975?
Provide a short and direct response. 0.84. What is the ratio of the Value added (in %) in Trinidad and Tobago in 1970 to that in 1975?
Give a very brief answer. 1.01. What is the ratio of the Value added (in %) of Cameroon in 1970 to that in 1976?
Make the answer very short. 0.97. What is the ratio of the Value added (in %) in Ecuador in 1970 to that in 1976?
Offer a very short reply. 1.05. What is the ratio of the Value added (in %) of Iraq in 1970 to that in 1976?
Provide a succinct answer. 0.9. What is the ratio of the Value added (in %) in Trinidad and Tobago in 1970 to that in 1976?
Give a very brief answer. 0.84. What is the ratio of the Value added (in %) in Cameroon in 1970 to that in 1977?
Keep it short and to the point. 1.31. What is the ratio of the Value added (in %) in Ecuador in 1970 to that in 1977?
Ensure brevity in your answer.  1.05. What is the ratio of the Value added (in %) in Iraq in 1970 to that in 1977?
Your answer should be very brief. 0.86. What is the ratio of the Value added (in %) in Trinidad and Tobago in 1970 to that in 1977?
Provide a short and direct response. 0.84. What is the ratio of the Value added (in %) of Cameroon in 1970 to that in 1984?
Keep it short and to the point. 1.54. What is the ratio of the Value added (in %) in Ecuador in 1970 to that in 1984?
Make the answer very short. 1.09. What is the ratio of the Value added (in %) of Iraq in 1970 to that in 1984?
Provide a short and direct response. 1.24. What is the ratio of the Value added (in %) of Trinidad and Tobago in 1970 to that in 1984?
Your answer should be compact. 0.61. What is the ratio of the Value added (in %) in Cameroon in 1971 to that in 1972?
Offer a terse response. 1.13. What is the ratio of the Value added (in %) in Ecuador in 1971 to that in 1972?
Provide a succinct answer. 0.9. What is the ratio of the Value added (in %) in Iraq in 1971 to that in 1972?
Provide a short and direct response. 0.88. What is the ratio of the Value added (in %) of Trinidad and Tobago in 1971 to that in 1972?
Give a very brief answer. 1.07. What is the ratio of the Value added (in %) in Cameroon in 1971 to that in 1974?
Offer a very short reply. 1.16. What is the ratio of the Value added (in %) of Iraq in 1971 to that in 1974?
Provide a short and direct response. 1.01. What is the ratio of the Value added (in %) in Trinidad and Tobago in 1971 to that in 1974?
Keep it short and to the point. 1.06. What is the ratio of the Value added (in %) in Cameroon in 1971 to that in 1975?
Offer a very short reply. 1.07. What is the ratio of the Value added (in %) of Ecuador in 1971 to that in 1975?
Your answer should be compact. 0.93. What is the ratio of the Value added (in %) in Iraq in 1971 to that in 1975?
Offer a very short reply. 1.19. What is the ratio of the Value added (in %) of Trinidad and Tobago in 1971 to that in 1975?
Offer a very short reply. 1.04. What is the ratio of the Value added (in %) of Cameroon in 1971 to that in 1976?
Provide a short and direct response. 1.12. What is the ratio of the Value added (in %) of Ecuador in 1971 to that in 1976?
Your response must be concise. 1.04. What is the ratio of the Value added (in %) in Iraq in 1971 to that in 1976?
Your answer should be very brief. 1.29. What is the ratio of the Value added (in %) in Trinidad and Tobago in 1971 to that in 1976?
Keep it short and to the point. 0.86. What is the ratio of the Value added (in %) of Cameroon in 1971 to that in 1977?
Give a very brief answer. 1.51. What is the ratio of the Value added (in %) in Ecuador in 1971 to that in 1977?
Provide a succinct answer. 1.04. What is the ratio of the Value added (in %) in Iraq in 1971 to that in 1977?
Provide a short and direct response. 1.23. What is the ratio of the Value added (in %) of Trinidad and Tobago in 1971 to that in 1977?
Your answer should be compact. 0.87. What is the ratio of the Value added (in %) of Cameroon in 1971 to that in 1984?
Keep it short and to the point. 1.78. What is the ratio of the Value added (in %) of Ecuador in 1971 to that in 1984?
Offer a terse response. 1.08. What is the ratio of the Value added (in %) of Iraq in 1971 to that in 1984?
Make the answer very short. 1.77. What is the ratio of the Value added (in %) in Trinidad and Tobago in 1971 to that in 1984?
Your answer should be compact. 0.62. What is the ratio of the Value added (in %) in Cameroon in 1972 to that in 1974?
Your answer should be very brief. 1.03. What is the ratio of the Value added (in %) in Ecuador in 1972 to that in 1974?
Offer a very short reply. 1.11. What is the ratio of the Value added (in %) in Iraq in 1972 to that in 1974?
Your answer should be very brief. 1.16. What is the ratio of the Value added (in %) in Trinidad and Tobago in 1972 to that in 1974?
Give a very brief answer. 0.99. What is the ratio of the Value added (in %) in Cameroon in 1972 to that in 1975?
Your response must be concise. 0.95. What is the ratio of the Value added (in %) of Ecuador in 1972 to that in 1975?
Give a very brief answer. 1.04. What is the ratio of the Value added (in %) of Iraq in 1972 to that in 1975?
Your answer should be compact. 1.36. What is the ratio of the Value added (in %) in Trinidad and Tobago in 1972 to that in 1975?
Your response must be concise. 0.98. What is the ratio of the Value added (in %) in Ecuador in 1972 to that in 1976?
Your response must be concise. 1.16. What is the ratio of the Value added (in %) of Iraq in 1972 to that in 1976?
Make the answer very short. 1.47. What is the ratio of the Value added (in %) in Trinidad and Tobago in 1972 to that in 1976?
Your answer should be very brief. 0.8. What is the ratio of the Value added (in %) of Cameroon in 1972 to that in 1977?
Provide a short and direct response. 1.34. What is the ratio of the Value added (in %) in Ecuador in 1972 to that in 1977?
Give a very brief answer. 1.15. What is the ratio of the Value added (in %) of Iraq in 1972 to that in 1977?
Your answer should be compact. 1.4. What is the ratio of the Value added (in %) of Trinidad and Tobago in 1972 to that in 1977?
Offer a very short reply. 0.81. What is the ratio of the Value added (in %) of Cameroon in 1972 to that in 1984?
Provide a short and direct response. 1.58. What is the ratio of the Value added (in %) of Ecuador in 1972 to that in 1984?
Provide a short and direct response. 1.2. What is the ratio of the Value added (in %) in Iraq in 1972 to that in 1984?
Provide a short and direct response. 2.02. What is the ratio of the Value added (in %) of Trinidad and Tobago in 1972 to that in 1984?
Provide a succinct answer. 0.58. What is the ratio of the Value added (in %) in Cameroon in 1974 to that in 1975?
Offer a terse response. 0.92. What is the ratio of the Value added (in %) of Ecuador in 1974 to that in 1975?
Offer a very short reply. 0.94. What is the ratio of the Value added (in %) of Iraq in 1974 to that in 1975?
Provide a short and direct response. 1.18. What is the ratio of the Value added (in %) of Trinidad and Tobago in 1974 to that in 1975?
Your response must be concise. 0.98. What is the ratio of the Value added (in %) in Cameroon in 1974 to that in 1976?
Ensure brevity in your answer.  0.97. What is the ratio of the Value added (in %) of Ecuador in 1974 to that in 1976?
Keep it short and to the point. 1.04. What is the ratio of the Value added (in %) in Iraq in 1974 to that in 1976?
Offer a terse response. 1.27. What is the ratio of the Value added (in %) in Trinidad and Tobago in 1974 to that in 1976?
Provide a short and direct response. 0.81. What is the ratio of the Value added (in %) in Cameroon in 1974 to that in 1977?
Offer a very short reply. 1.3. What is the ratio of the Value added (in %) in Ecuador in 1974 to that in 1977?
Provide a short and direct response. 1.04. What is the ratio of the Value added (in %) in Iraq in 1974 to that in 1977?
Provide a short and direct response. 1.21. What is the ratio of the Value added (in %) of Trinidad and Tobago in 1974 to that in 1977?
Your response must be concise. 0.82. What is the ratio of the Value added (in %) in Cameroon in 1974 to that in 1984?
Ensure brevity in your answer.  1.53. What is the ratio of the Value added (in %) in Ecuador in 1974 to that in 1984?
Make the answer very short. 1.08. What is the ratio of the Value added (in %) in Iraq in 1974 to that in 1984?
Your answer should be compact. 1.75. What is the ratio of the Value added (in %) of Trinidad and Tobago in 1974 to that in 1984?
Your answer should be compact. 0.59. What is the ratio of the Value added (in %) in Cameroon in 1975 to that in 1976?
Your answer should be compact. 1.05. What is the ratio of the Value added (in %) in Ecuador in 1975 to that in 1976?
Provide a succinct answer. 1.11. What is the ratio of the Value added (in %) in Iraq in 1975 to that in 1976?
Your response must be concise. 1.08. What is the ratio of the Value added (in %) in Trinidad and Tobago in 1975 to that in 1976?
Offer a terse response. 0.82. What is the ratio of the Value added (in %) in Cameroon in 1975 to that in 1977?
Give a very brief answer. 1.42. What is the ratio of the Value added (in %) in Ecuador in 1975 to that in 1977?
Your answer should be very brief. 1.11. What is the ratio of the Value added (in %) of Iraq in 1975 to that in 1977?
Offer a terse response. 1.03. What is the ratio of the Value added (in %) of Trinidad and Tobago in 1975 to that in 1977?
Keep it short and to the point. 0.83. What is the ratio of the Value added (in %) of Cameroon in 1975 to that in 1984?
Make the answer very short. 1.66. What is the ratio of the Value added (in %) of Ecuador in 1975 to that in 1984?
Offer a terse response. 1.16. What is the ratio of the Value added (in %) of Iraq in 1975 to that in 1984?
Your answer should be very brief. 1.48. What is the ratio of the Value added (in %) of Trinidad and Tobago in 1975 to that in 1984?
Provide a short and direct response. 0.6. What is the ratio of the Value added (in %) of Cameroon in 1976 to that in 1977?
Offer a terse response. 1.35. What is the ratio of the Value added (in %) of Ecuador in 1976 to that in 1977?
Offer a very short reply. 1. What is the ratio of the Value added (in %) of Iraq in 1976 to that in 1977?
Your answer should be compact. 0.95. What is the ratio of the Value added (in %) in Trinidad and Tobago in 1976 to that in 1977?
Keep it short and to the point. 1.01. What is the ratio of the Value added (in %) of Cameroon in 1976 to that in 1984?
Your response must be concise. 1.59. What is the ratio of the Value added (in %) in Ecuador in 1976 to that in 1984?
Provide a short and direct response. 1.04. What is the ratio of the Value added (in %) in Iraq in 1976 to that in 1984?
Keep it short and to the point. 1.37. What is the ratio of the Value added (in %) of Trinidad and Tobago in 1976 to that in 1984?
Give a very brief answer. 0.73. What is the ratio of the Value added (in %) of Cameroon in 1977 to that in 1984?
Offer a terse response. 1.18. What is the ratio of the Value added (in %) of Ecuador in 1977 to that in 1984?
Give a very brief answer. 1.04. What is the ratio of the Value added (in %) of Iraq in 1977 to that in 1984?
Keep it short and to the point. 1.44. What is the ratio of the Value added (in %) in Trinidad and Tobago in 1977 to that in 1984?
Provide a short and direct response. 0.72. What is the difference between the highest and the second highest Value added (in %) of Cameroon?
Provide a succinct answer. 1.14. What is the difference between the highest and the second highest Value added (in %) in Ecuador?
Provide a short and direct response. 0.59. What is the difference between the highest and the second highest Value added (in %) of Iraq?
Your answer should be compact. 2.9. What is the difference between the highest and the second highest Value added (in %) in Trinidad and Tobago?
Offer a terse response. 1.53. What is the difference between the highest and the lowest Value added (in %) of Cameroon?
Provide a succinct answer. 7.62. What is the difference between the highest and the lowest Value added (in %) in Ecuador?
Ensure brevity in your answer.  2.64. What is the difference between the highest and the lowest Value added (in %) in Iraq?
Your answer should be compact. 11.82. What is the difference between the highest and the lowest Value added (in %) in Trinidad and Tobago?
Provide a short and direct response. 2.33. 